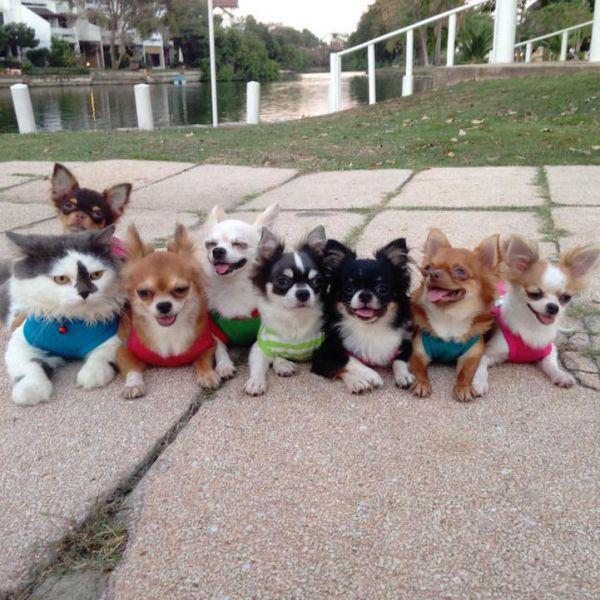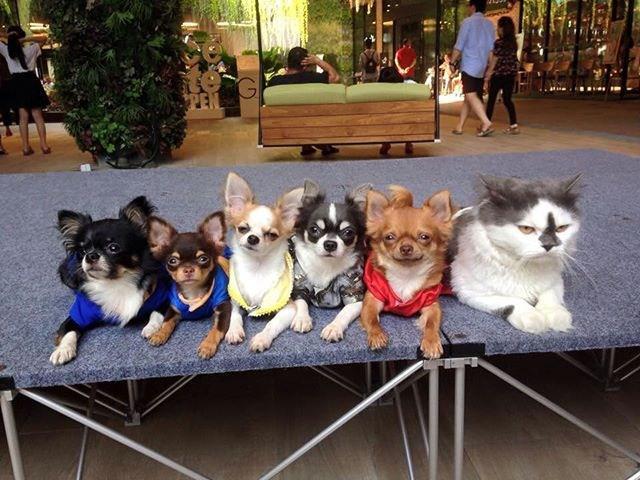The first image is the image on the left, the second image is the image on the right. Considering the images on both sides, is "Each image shows a row of dressed dogs posing with a cat that is also wearing some garment." valid? Answer yes or no. No. 